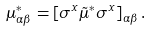Convert formula to latex. <formula><loc_0><loc_0><loc_500><loc_500>\mu ^ { * } _ { \alpha \beta } = \left [ \sigma ^ { x } \tilde { \mu } ^ { * } \sigma ^ { x } \right ] _ { \alpha \beta } .</formula> 